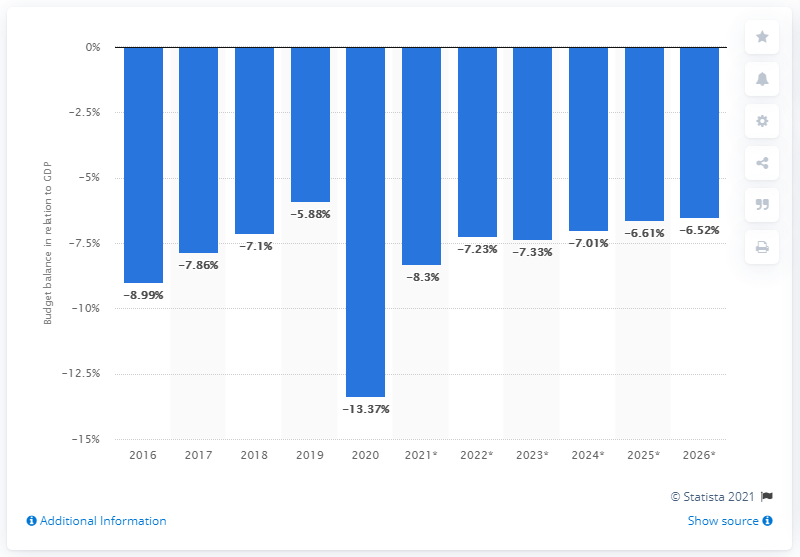Specify some key components in this picture. In 2020, the budget balance in relation to GDP in Brazil came to an end. 